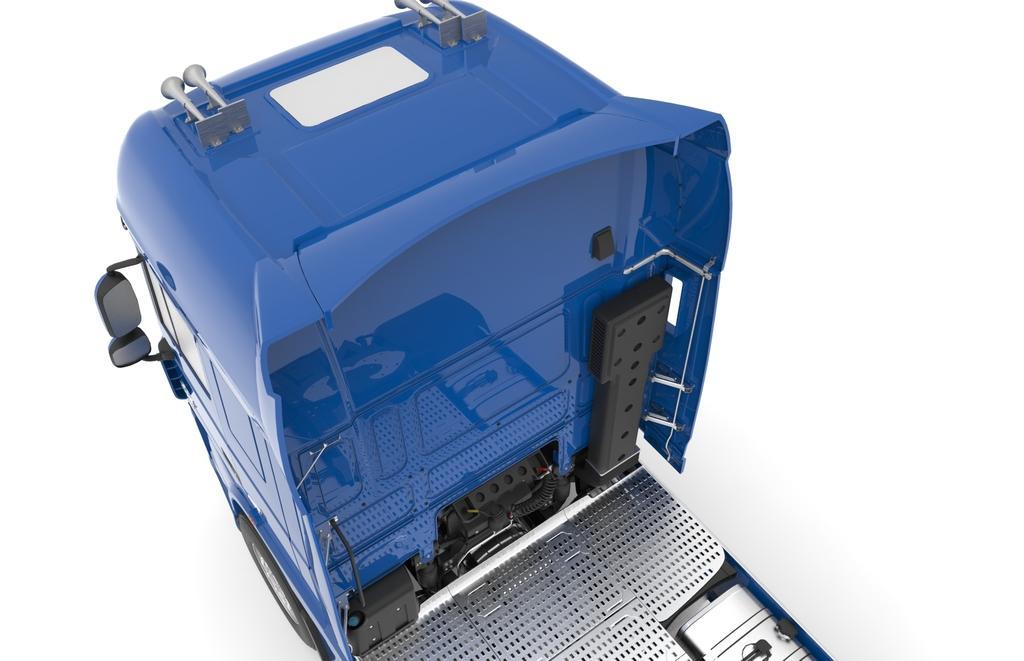Can you describe this image briefly? In this picture I can observe a truck which is in blue color. The background is in white color. 